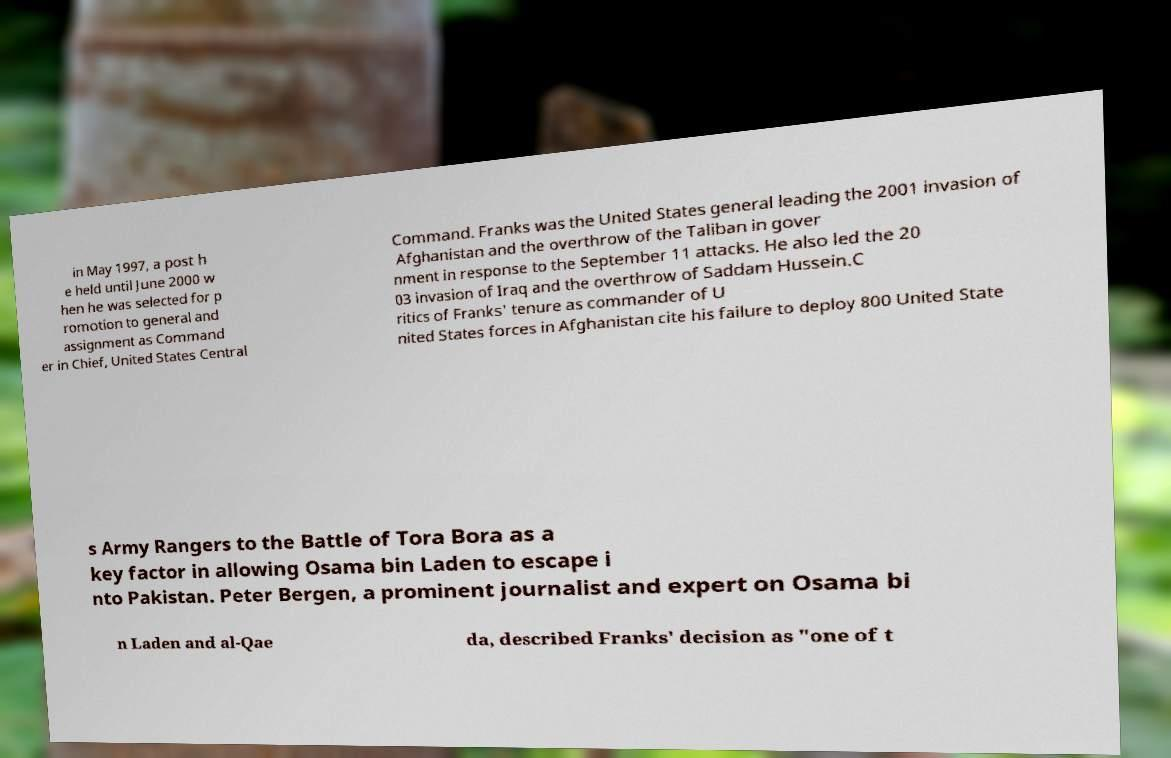Could you assist in decoding the text presented in this image and type it out clearly? in May 1997, a post h e held until June 2000 w hen he was selected for p romotion to general and assignment as Command er in Chief, United States Central Command. Franks was the United States general leading the 2001 invasion of Afghanistan and the overthrow of the Taliban in gover nment in response to the September 11 attacks. He also led the 20 03 invasion of Iraq and the overthrow of Saddam Hussein.C ritics of Franks' tenure as commander of U nited States forces in Afghanistan cite his failure to deploy 800 United State s Army Rangers to the Battle of Tora Bora as a key factor in allowing Osama bin Laden to escape i nto Pakistan. Peter Bergen, a prominent journalist and expert on Osama bi n Laden and al-Qae da, described Franks' decision as "one of t 